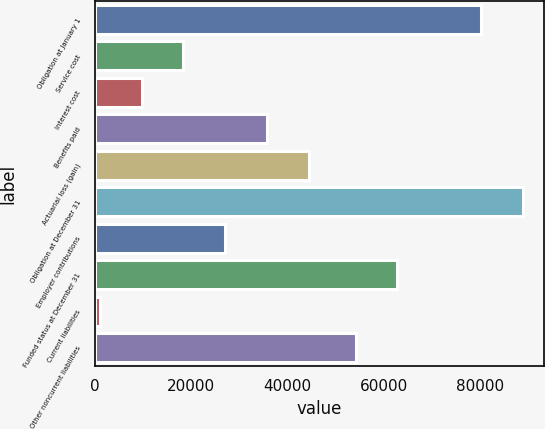Convert chart to OTSL. <chart><loc_0><loc_0><loc_500><loc_500><bar_chart><fcel>Obligation at January 1<fcel>Service cost<fcel>Interest cost<fcel>Benefits paid<fcel>Actuarial loss (gain)<fcel>Obligation at December 31<fcel>Employer contributions<fcel>Funded status at December 31<fcel>Current liabilities<fcel>Other noncurrent liabilities<nl><fcel>80200.7<fcel>18356.8<fcel>9680.9<fcel>35708.6<fcel>44384.5<fcel>88876.6<fcel>27032.7<fcel>62848.9<fcel>1005<fcel>54173<nl></chart> 